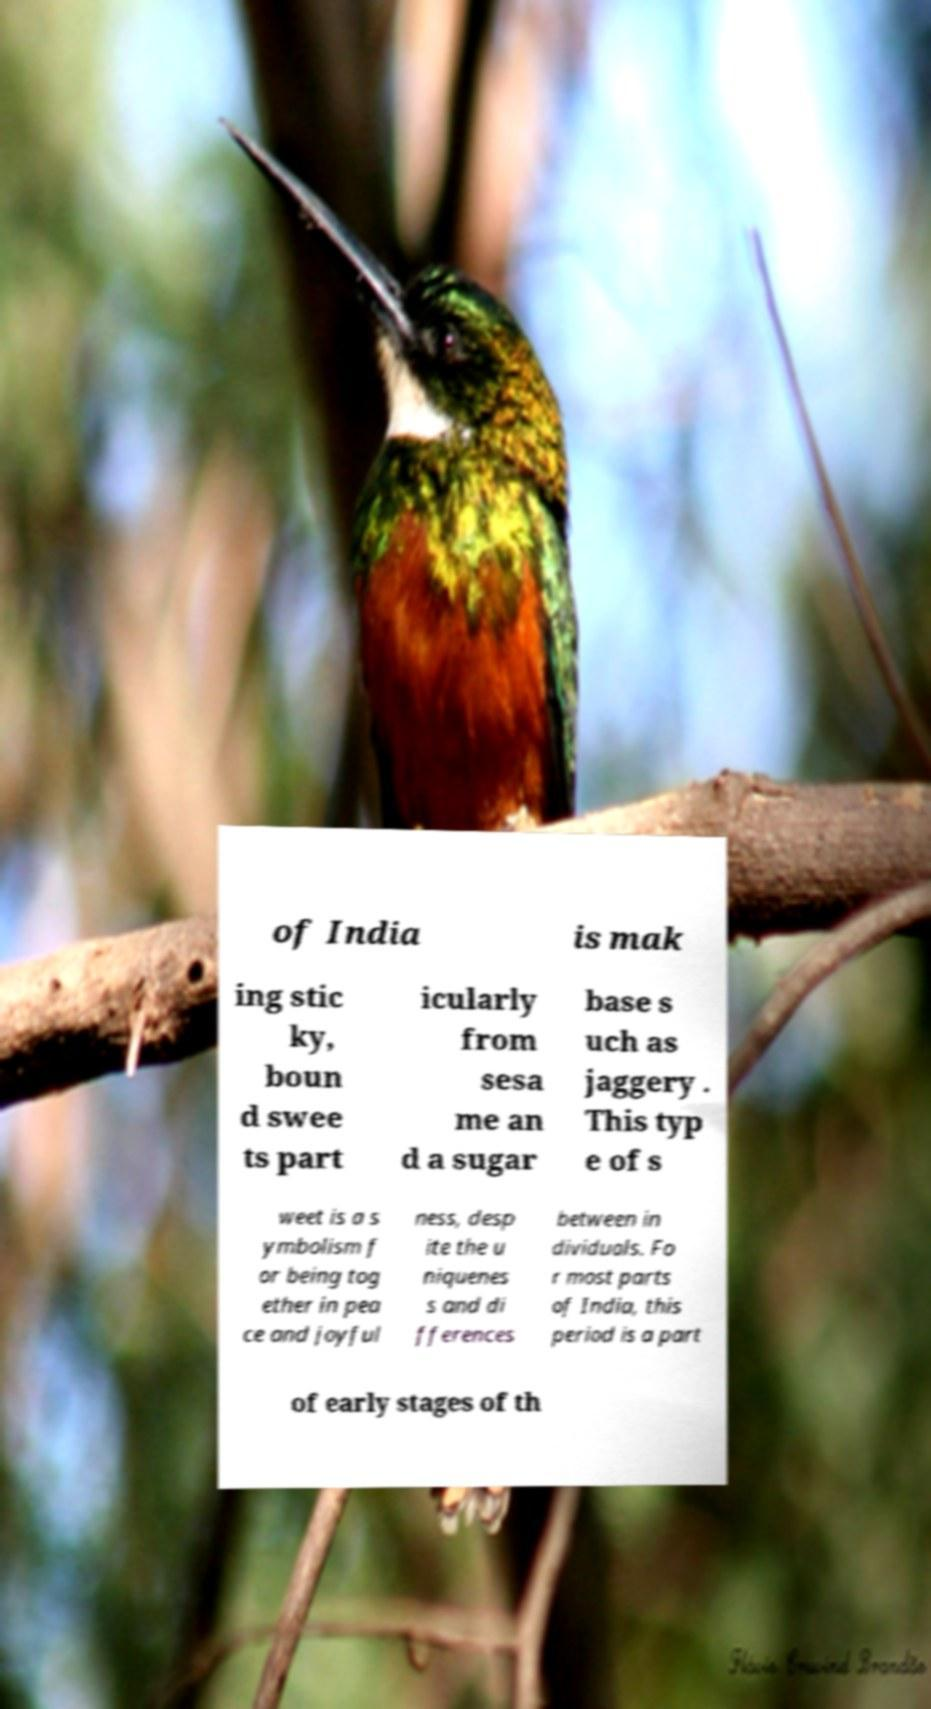Please identify and transcribe the text found in this image. of India is mak ing stic ky, boun d swee ts part icularly from sesa me an d a sugar base s uch as jaggery . This typ e of s weet is a s ymbolism f or being tog ether in pea ce and joyful ness, desp ite the u niquenes s and di fferences between in dividuals. Fo r most parts of India, this period is a part of early stages of th 